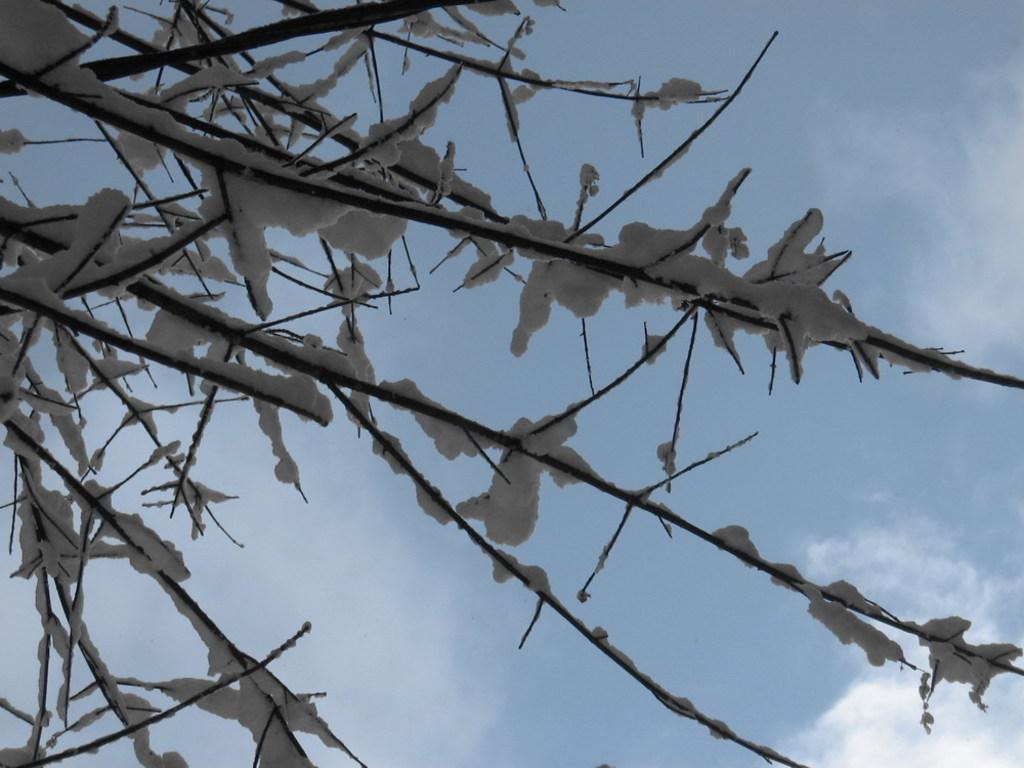What is present on the branches in the image? There is snow on the branches in the image. What can be seen in the background of the image? Sky is visible in the background of the image. What is the condition of the sky in the image? Clouds are present in the sky. What type of note is attached to the stem of the snow-covered branch in the image? There is no note or stem present in the image; it only features branches with snow and a sky with clouds. 